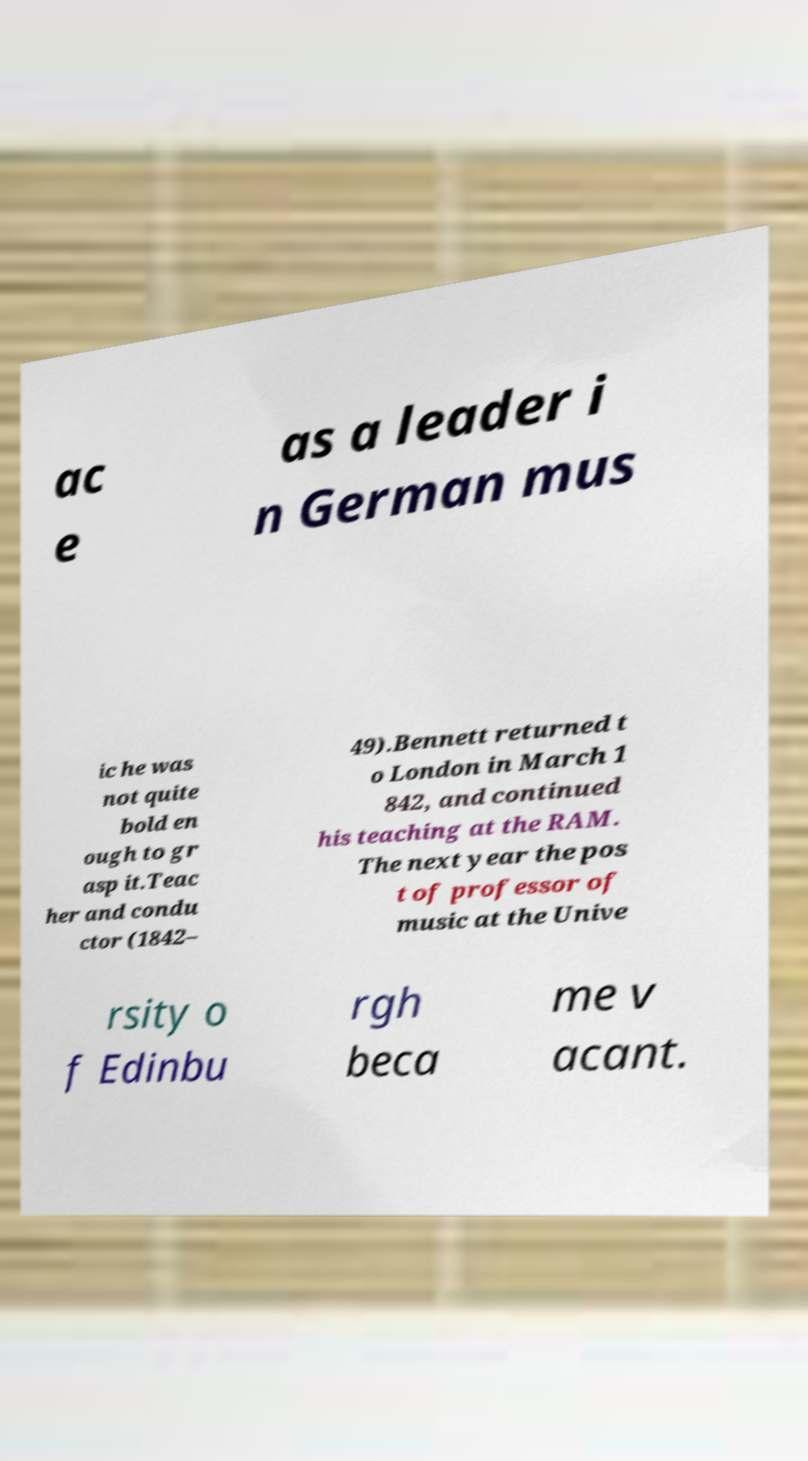Please read and relay the text visible in this image. What does it say? ac e as a leader i n German mus ic he was not quite bold en ough to gr asp it.Teac her and condu ctor (1842– 49).Bennett returned t o London in March 1 842, and continued his teaching at the RAM. The next year the pos t of professor of music at the Unive rsity o f Edinbu rgh beca me v acant. 